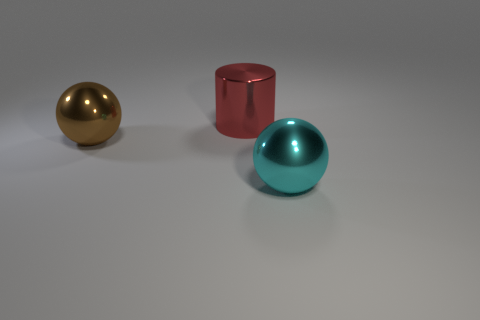Are there any other things that are the same shape as the large red object?
Give a very brief answer. No. There is a brown object that is the same shape as the big cyan metal thing; what is it made of?
Keep it short and to the point. Metal. How many red cubes have the same size as the cyan metallic ball?
Ensure brevity in your answer.  0. What color is the large cylinder that is the same material as the brown sphere?
Your response must be concise. Red. Are there fewer big cyan metal objects than green matte cylinders?
Provide a succinct answer. No. How many cyan things are balls or big things?
Offer a terse response. 1. What number of big spheres are both on the right side of the large brown shiny ball and behind the big cyan thing?
Your response must be concise. 0. Is the material of the large red cylinder the same as the big brown ball?
Give a very brief answer. Yes. What is the shape of the cyan object that is the same size as the red object?
Offer a very short reply. Sphere. Is the number of big spheres greater than the number of red rubber objects?
Offer a very short reply. Yes. 